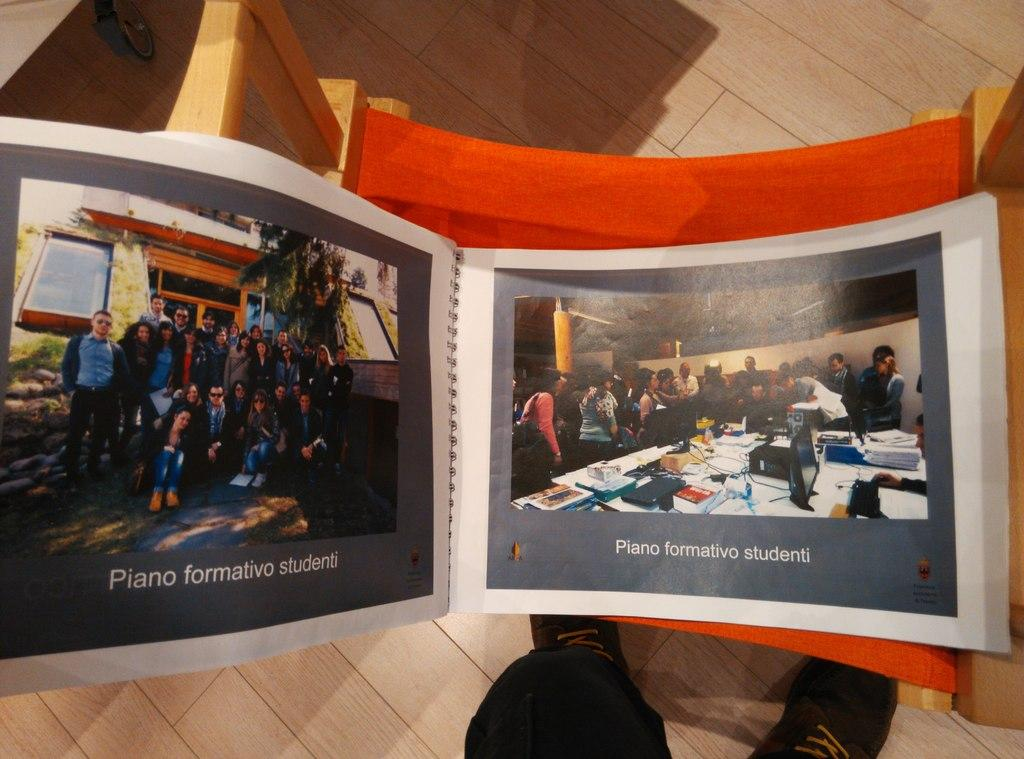<image>
Describe the image concisely. A book of photos labeled Piano formativo studenti. 